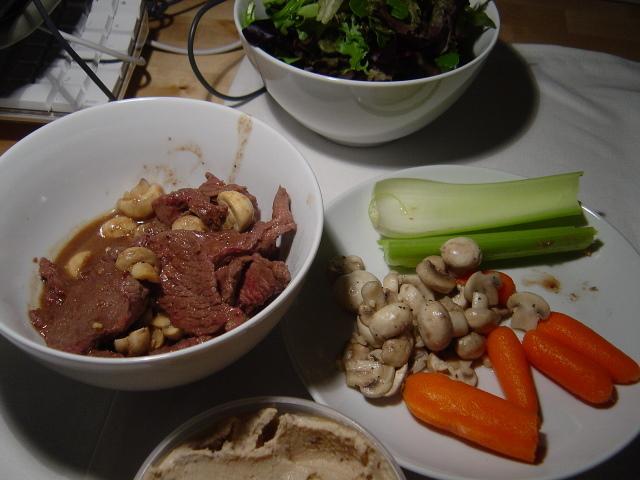How many sushi rolls are shown?
Short answer required. 0. What color is the pot?
Be succinct. White. What type of vegetable is on the plate?
Quick response, please. Carrots. Is there a coffee cup?
Write a very short answer. No. What are the long green vegetables?
Short answer required. Celery. Is there any identifiable meat in this dish?
Keep it brief. Yes. Are these food items mini pizzas?
Be succinct. No. Which object have happy faces?
Answer briefly. 0. Are the plates disposable?
Quick response, please. No. What shape are the carrots?
Be succinct. Tubular. What kind of vegetable is on the plate?
Quick response, please. Carrot. Do this kitchen appear recently cleaned?
Be succinct. No. What is the green vegetable on the plate?
Concise answer only. Celery. Are any vegetables here?
Short answer required. Yes. Are these real carrots?
Be succinct. Yes. How many carrots are there?
Keep it brief. 4. What is sliced on the right plate?
Write a very short answer. Celery. What is on the right plate?
Be succinct. Vegetables. Could these be sliced yams?
Answer briefly. No. What is the plate made of?
Keep it brief. Ceramic. Is this meal vegetarian?
Write a very short answer. No. Where are the carrots?
Write a very short answer. Plate. Is the food eaten?
Quick response, please. No. Have the carrots been peeled?
Concise answer only. Yes. Is there tupperware?
Give a very brief answer. No. What kind of food is on the plate?
Keep it brief. Vegetables. How many slices of celery are there?
Be succinct. 2. What kind of meat is in this picture?
Quick response, please. Beef. What food dish is on the plate?
Keep it brief. Salad. What sort of condiment has been drizzled on the dish?
Concise answer only. Gravy. What vegetable is on the plate?
Write a very short answer. Carrot. Are these veggies or fruits?
Short answer required. Veggies. Is this meal vegetarian friendly?
Concise answer only. No. What is the green vegetable?
Keep it brief. Celery. Would a vegetarian eat this?
Give a very brief answer. No. What is mixed in with the carrots?
Short answer required. Mushrooms. Is there meat in the image?
Concise answer only. Yes. What type of food is on the right?
Keep it brief. Carrots. What is for lunch?
Give a very brief answer. Meat and veggies. What is in the bowl?
Answer briefly. Meat. What vegetable is here?
Answer briefly. Carrots and celery. What are the vegetables sitting on?
Write a very short answer. Plate. What types of vegetables are on the table?
Write a very short answer. Carrot. 